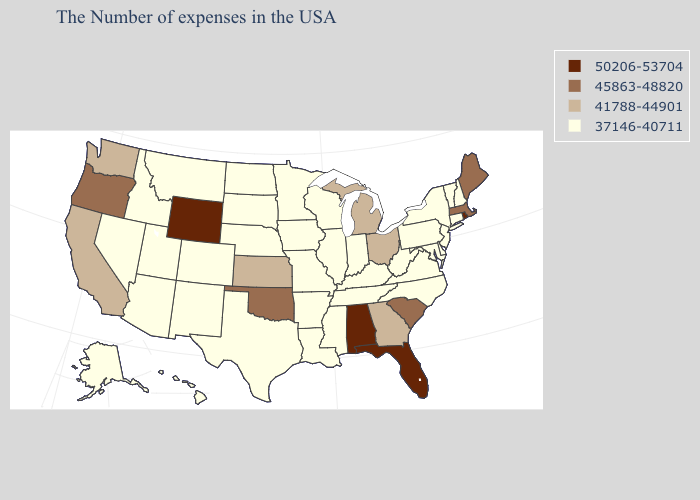Name the states that have a value in the range 45863-48820?
Be succinct. Maine, Massachusetts, South Carolina, Oklahoma, Oregon. Name the states that have a value in the range 37146-40711?
Short answer required. New Hampshire, Vermont, Connecticut, New York, New Jersey, Delaware, Maryland, Pennsylvania, Virginia, North Carolina, West Virginia, Kentucky, Indiana, Tennessee, Wisconsin, Illinois, Mississippi, Louisiana, Missouri, Arkansas, Minnesota, Iowa, Nebraska, Texas, South Dakota, North Dakota, Colorado, New Mexico, Utah, Montana, Arizona, Idaho, Nevada, Alaska, Hawaii. What is the lowest value in states that border California?
Concise answer only. 37146-40711. Name the states that have a value in the range 41788-44901?
Be succinct. Ohio, Georgia, Michigan, Kansas, California, Washington. Does Minnesota have the same value as New Mexico?
Concise answer only. Yes. What is the lowest value in states that border Delaware?
Quick response, please. 37146-40711. Among the states that border Arkansas , does Oklahoma have the highest value?
Short answer required. Yes. Among the states that border Massachusetts , which have the highest value?
Short answer required. Rhode Island. What is the highest value in states that border Louisiana?
Write a very short answer. 37146-40711. Does Iowa have the highest value in the USA?
Answer briefly. No. What is the lowest value in the USA?
Answer briefly. 37146-40711. What is the value of Missouri?
Be succinct. 37146-40711. Which states have the lowest value in the USA?
Be succinct. New Hampshire, Vermont, Connecticut, New York, New Jersey, Delaware, Maryland, Pennsylvania, Virginia, North Carolina, West Virginia, Kentucky, Indiana, Tennessee, Wisconsin, Illinois, Mississippi, Louisiana, Missouri, Arkansas, Minnesota, Iowa, Nebraska, Texas, South Dakota, North Dakota, Colorado, New Mexico, Utah, Montana, Arizona, Idaho, Nevada, Alaska, Hawaii. Does Kentucky have a higher value than Oregon?
Quick response, please. No. Among the states that border Arkansas , which have the highest value?
Quick response, please. Oklahoma. 